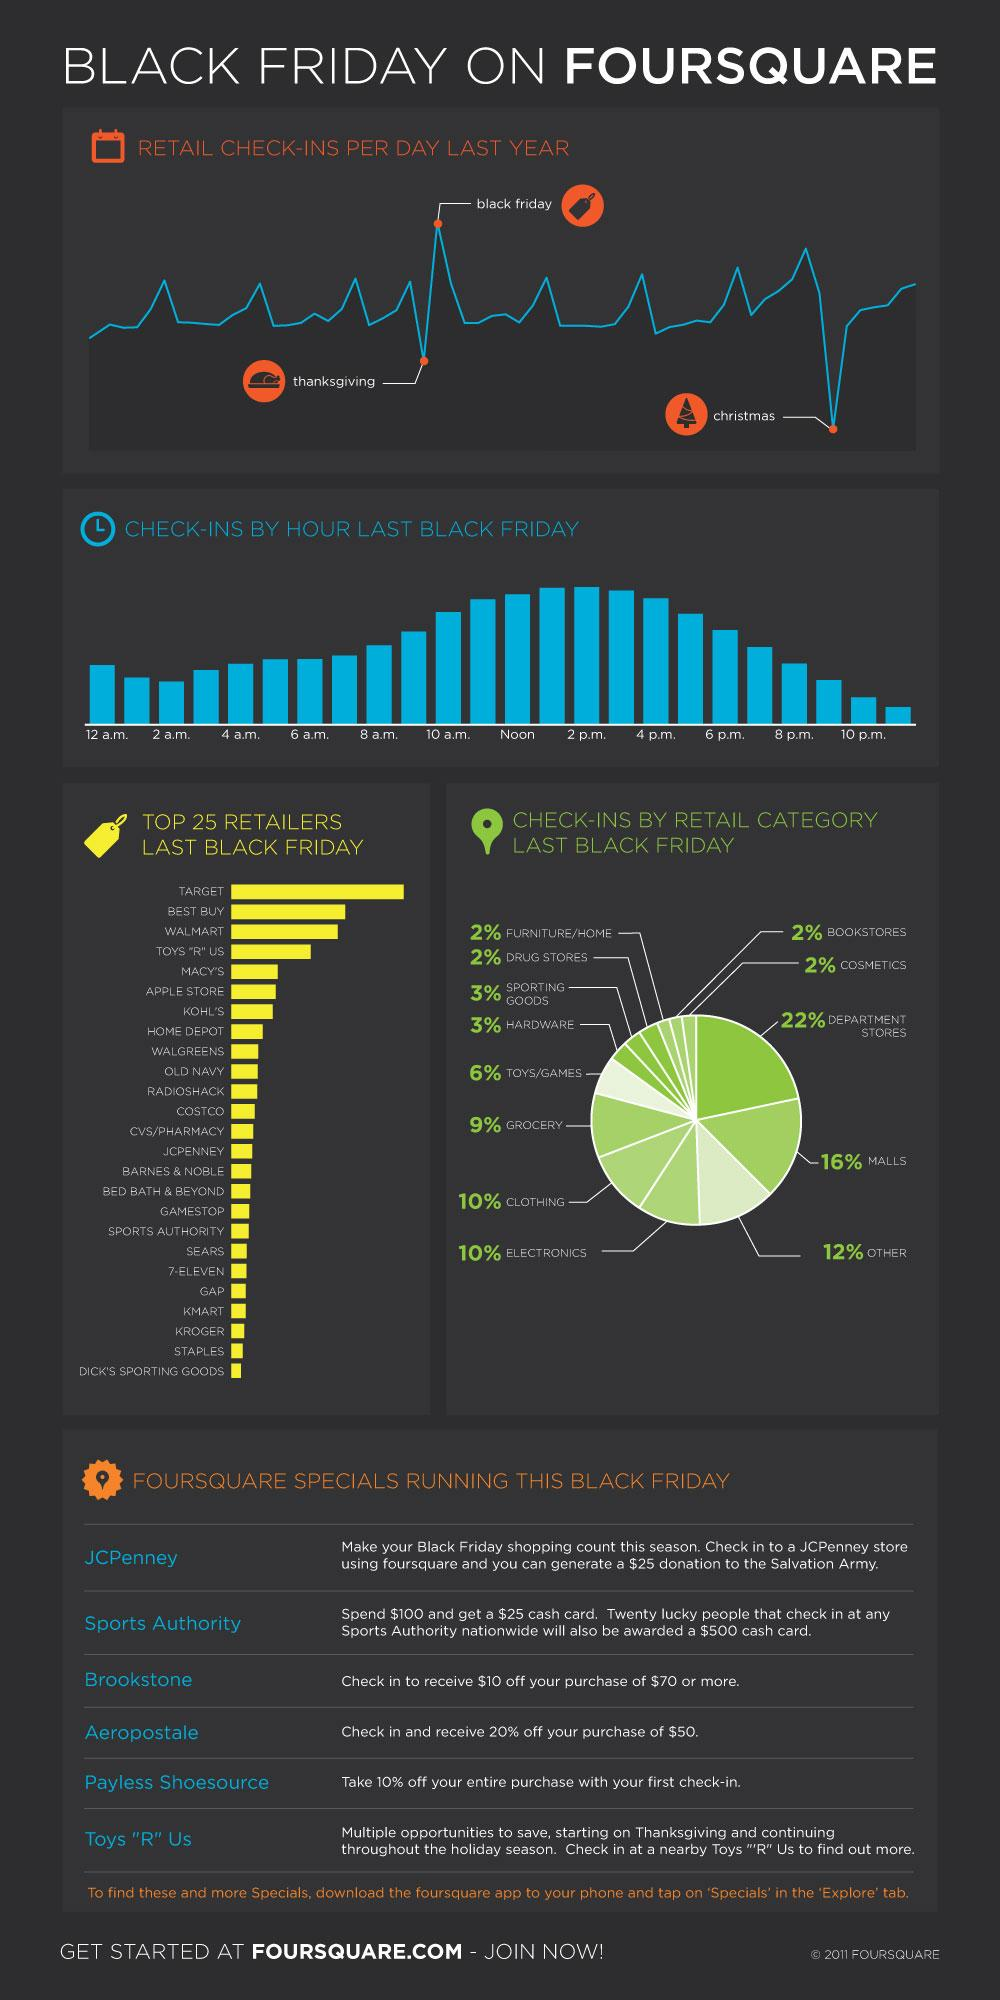Outline some significant characteristics in this image. The time with the lowest check-ins for Black Friday was 11 p.m. During the three shopping seasons, Christmas typically shows the greatest decrease in retail check-ins, indicating a decrease in consumer spending during the holiday season. In total, clothing and electronics account for 20% of all check-ins. On Black Friday, Target was the retailer that recorded the highest sales. Six stores are currently offering Four Square specials during Black Friday. 